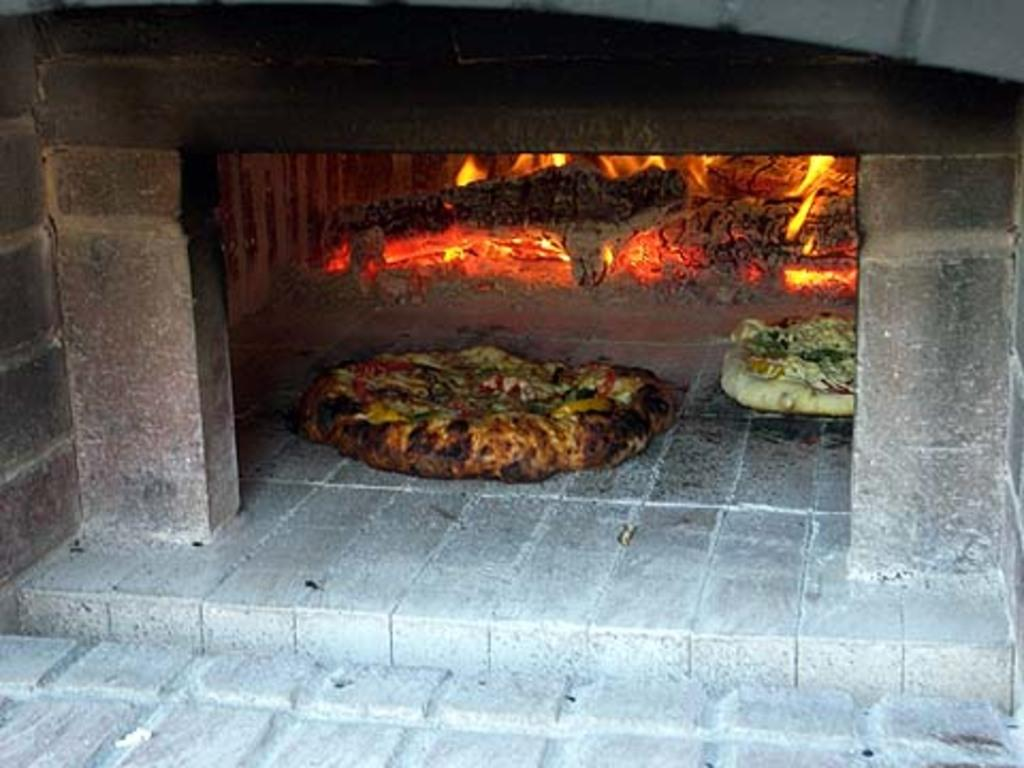What type of oven is in the image? There is a pizza oven in the image. What is inside the oven? There are two pizzas inside the oven. Can you describe the heat source for the oven? There is fire visible behind the oven. What type of disgust can be seen on the pizzas in the image? There is no indication of disgust on the pizzas in the image; they are simply inside the oven. 